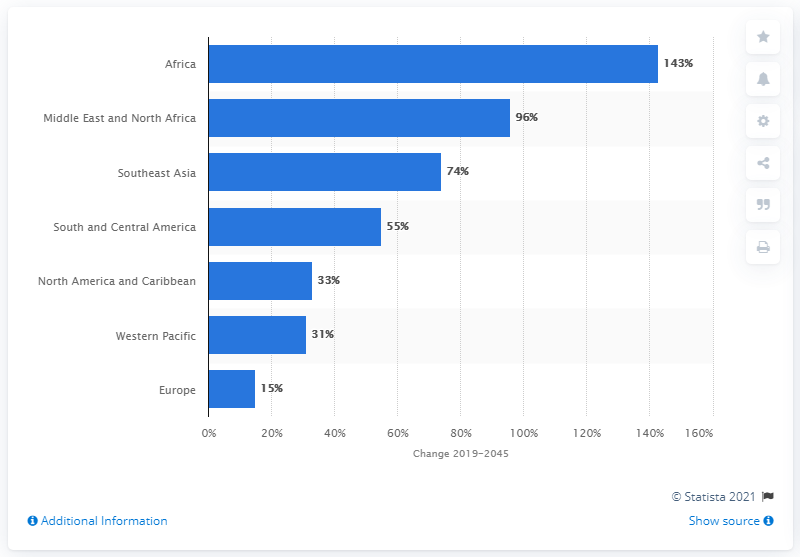Mention a couple of crucial points in this snapshot. It is expected that the number of diabetics in Europe between the ages of 20 and 79 will increase by 15% in the next few years. 